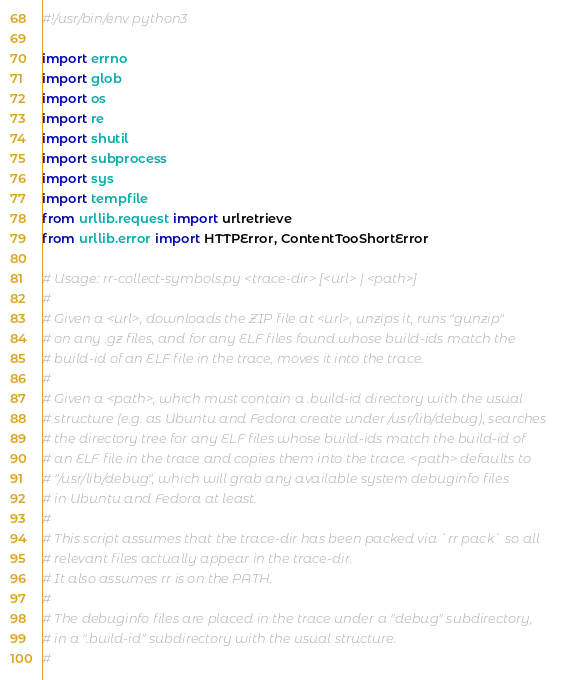<code> <loc_0><loc_0><loc_500><loc_500><_Python_>#!/usr/bin/env python3

import errno
import glob
import os
import re
import shutil
import subprocess
import sys
import tempfile
from urllib.request import urlretrieve
from urllib.error import HTTPError, ContentTooShortError

# Usage: rr-collect-symbols.py <trace-dir> [<url> | <path>]
#
# Given a <url>, downloads the ZIP file at <url>, unzips it, runs "gunzip"
# on any .gz files, and for any ELF files found whose build-ids match the
# build-id of an ELF file in the trace, moves it into the trace.
#
# Given a <path>, which must contain a .build-id directory with the usual
# structure (e.g. as Ubuntu and Fedora create under /usr/lib/debug), searches
# the directory tree for any ELF files whose build-ids match the build-id of
# an ELF file in the trace and copies them into the trace. <path> defaults to
# "/usr/lib/debug", which will grab any available system debuginfo files
# in Ubuntu and Fedora at least.
#
# This script assumes that the trace-dir has been packed via `rr pack` so all
# relevant files actually appear in the trace-dir.
# It also assumes rr is on the PATH.
#
# The debuginfo files are placed in the trace under a "debug" subdirectory,
# in a ".build-id" subdirectory with the usual structure.
#</code> 